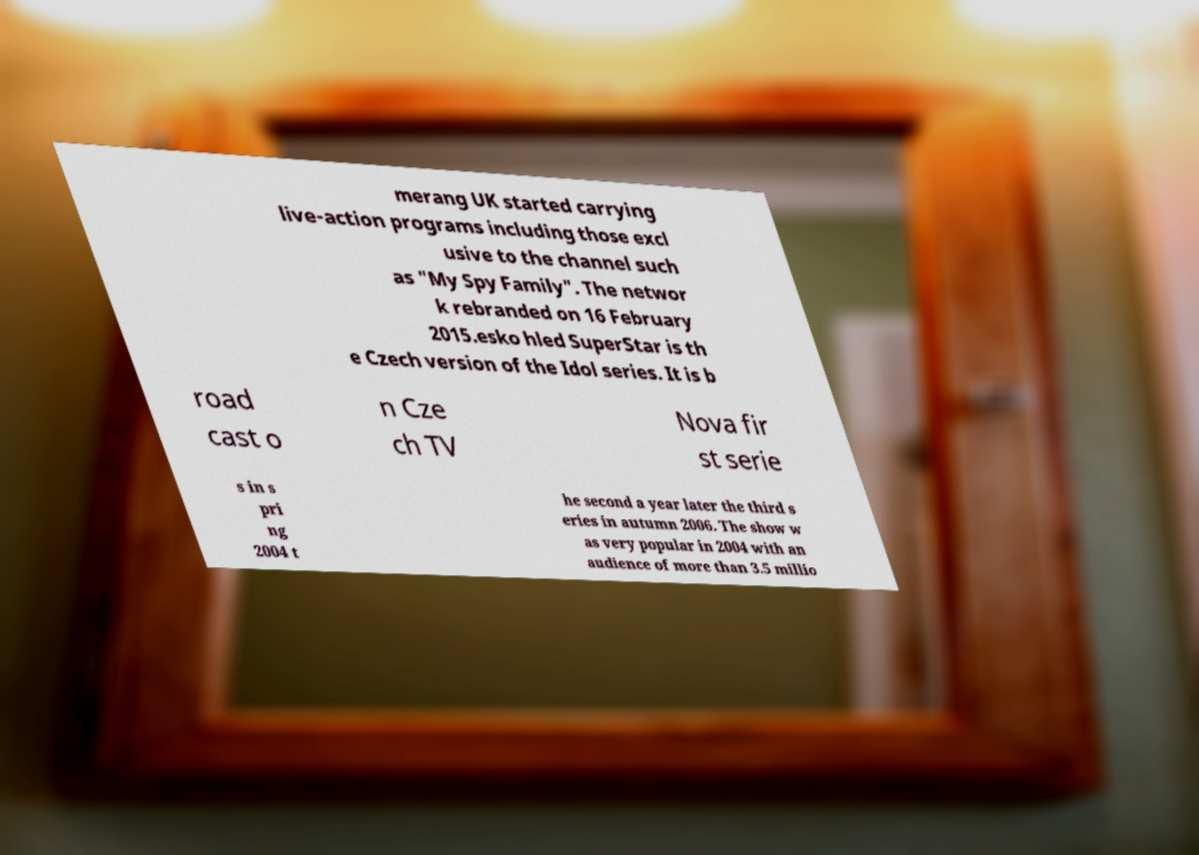For documentation purposes, I need the text within this image transcribed. Could you provide that? merang UK started carrying live-action programs including those excl usive to the channel such as "My Spy Family". The networ k rebranded on 16 February 2015.esko hled SuperStar is th e Czech version of the Idol series. It is b road cast o n Cze ch TV Nova fir st serie s in s pri ng 2004 t he second a year later the third s eries in autumn 2006. The show w as very popular in 2004 with an audience of more than 3.5 millio 